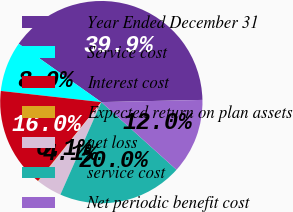Convert chart to OTSL. <chart><loc_0><loc_0><loc_500><loc_500><pie_chart><fcel>Year Ended December 31<fcel>Service cost<fcel>Interest cost<fcel>Expected return on plan assets<fcel>net loss<fcel>service cost<fcel>Net periodic benefit cost<nl><fcel>39.86%<fcel>8.03%<fcel>15.99%<fcel>0.08%<fcel>4.06%<fcel>19.97%<fcel>12.01%<nl></chart> 